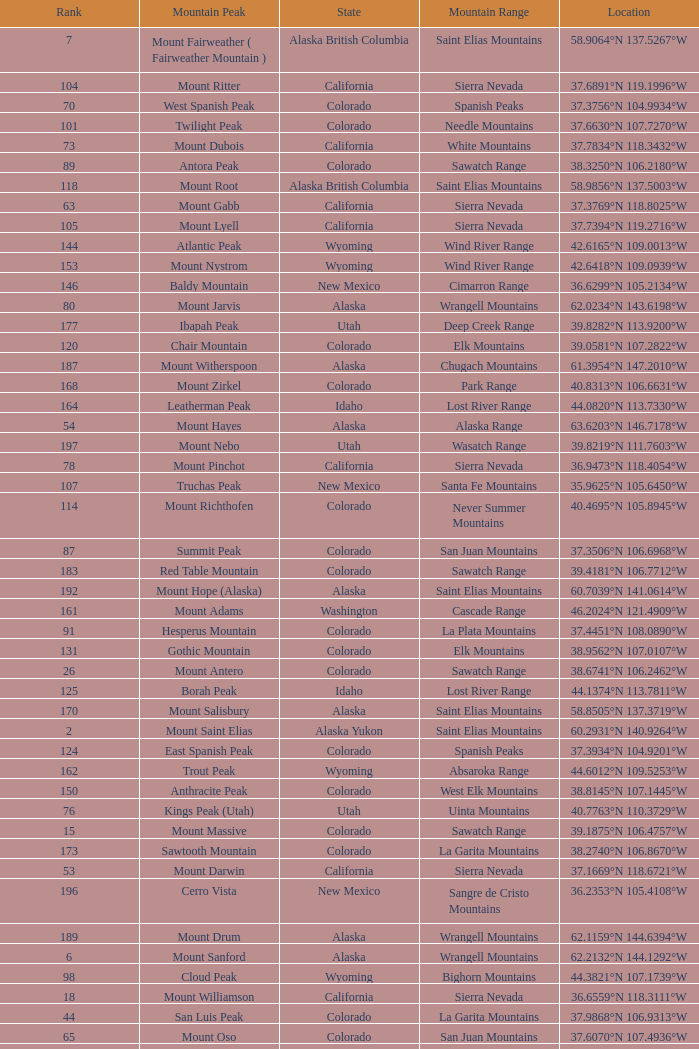What is the mountain peak when the location is 37.5775°n 105.4856°w? Blanca Peak. 